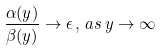Convert formula to latex. <formula><loc_0><loc_0><loc_500><loc_500>\frac { \alpha ( y ) } { \beta ( y ) } \to \epsilon \, , \, a s \, y \to \infty</formula> 